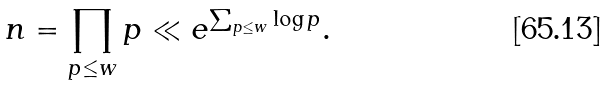<formula> <loc_0><loc_0><loc_500><loc_500>n = \prod _ { p \leq w } p \ll e ^ { \sum _ { p \leq w } \log p } .</formula> 